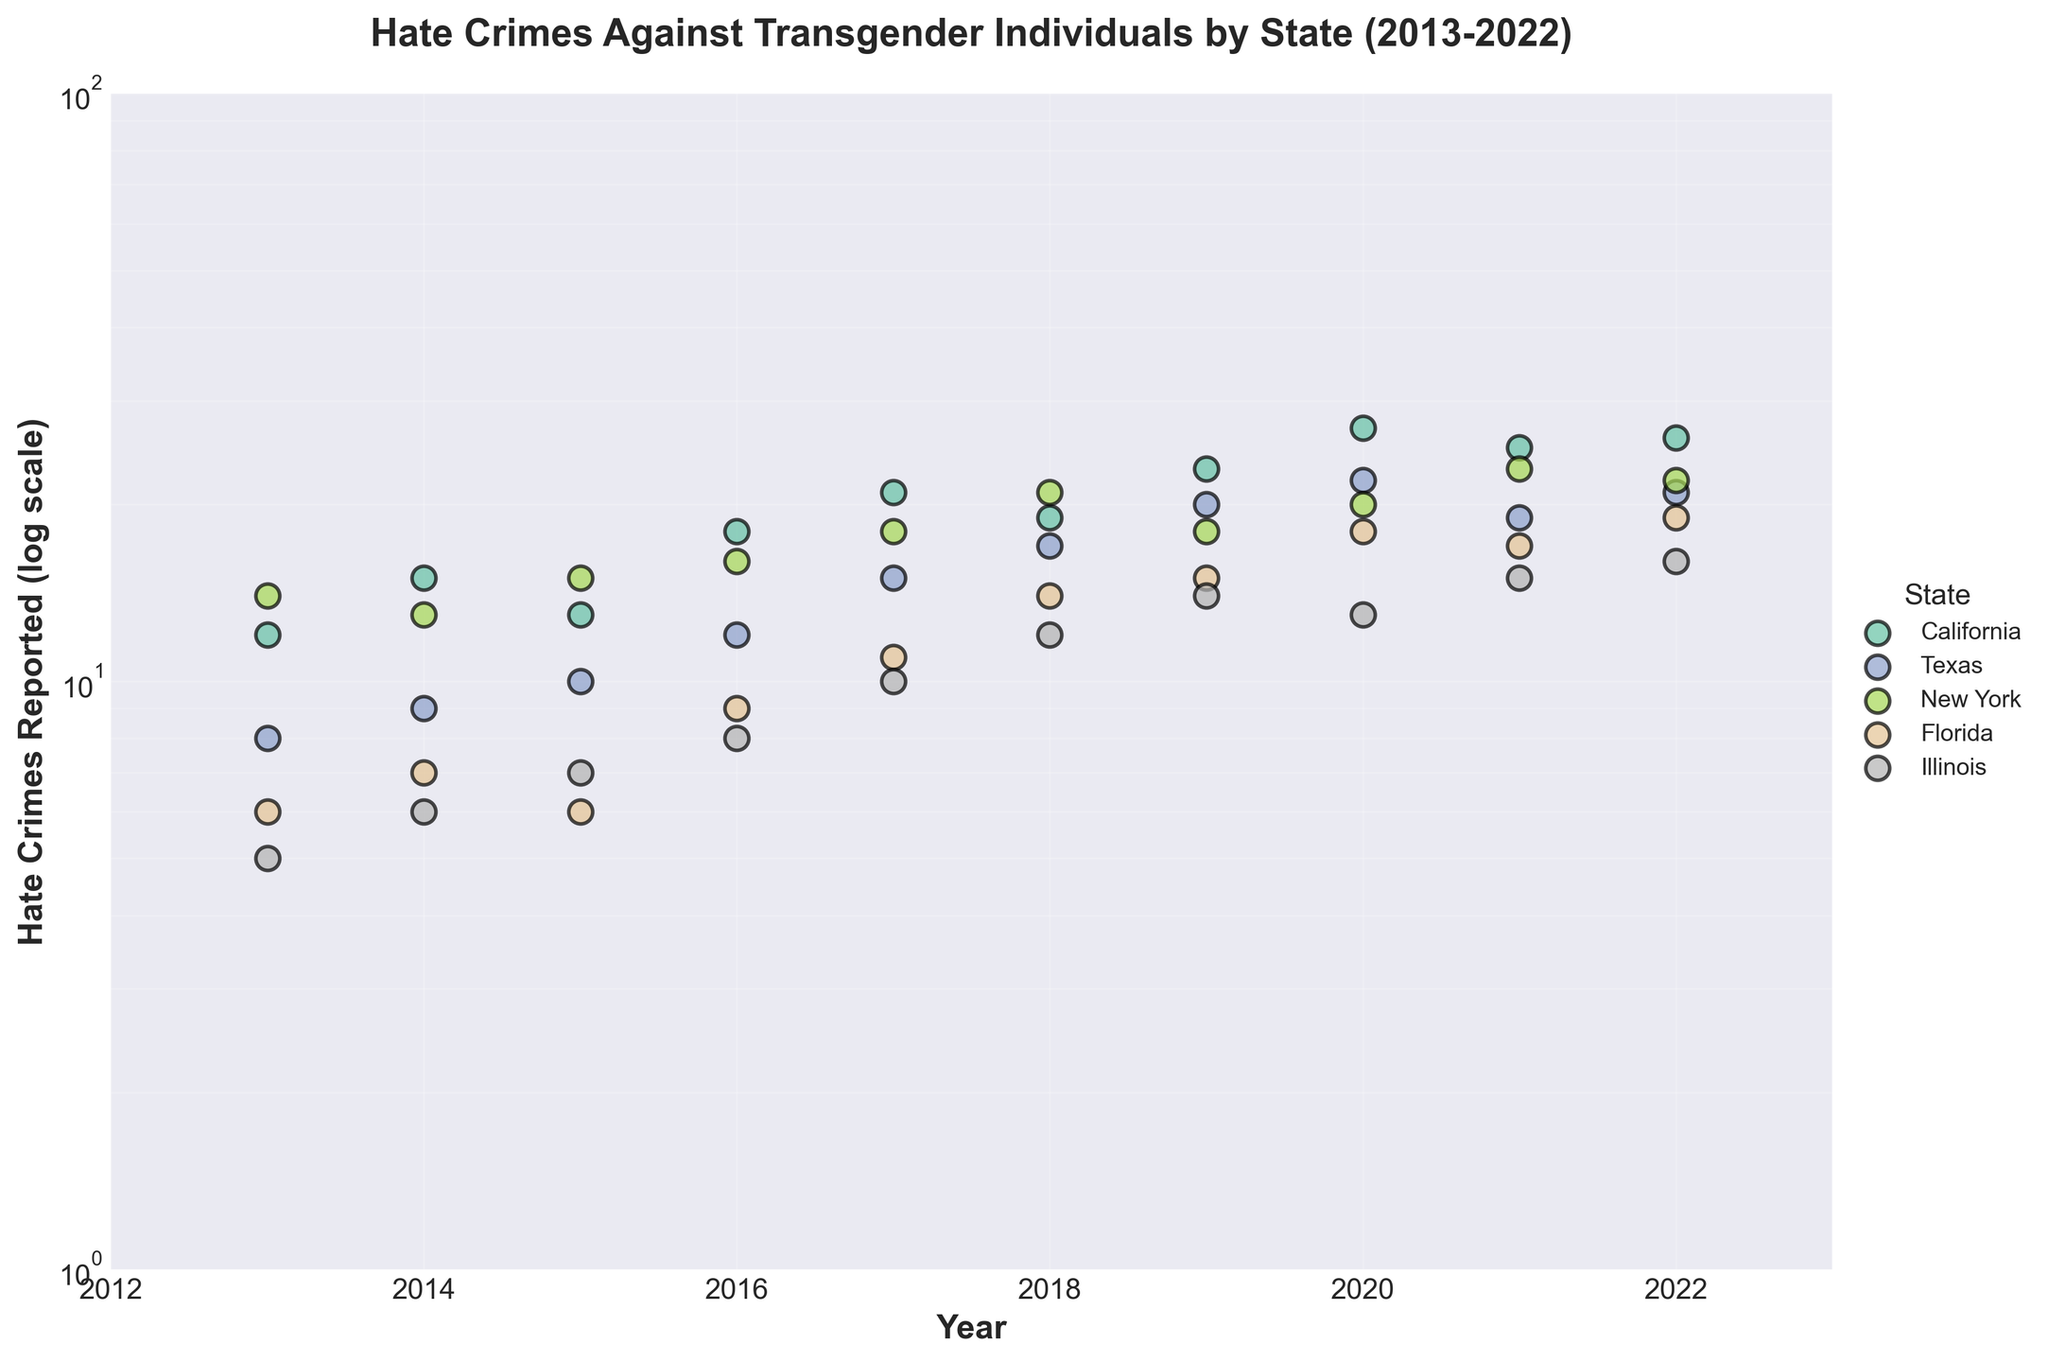What is the title of the figure? The title is typically located at the top of the figure. It is usually larger and bold.
Answer: Hate Crimes Against Transgender Individuals by State (2013-2022) Which state had the highest number of hate crimes reported in 2022? Observe the y-axis values for the year 2022, then identify the state corresponding to the highest y-axis value.
Answer: California How many hate crime incidents against transgender individuals were reported in Texas in 2017? Locate the section of the scatter plot corresponding to Texas for the year 2017, then read the y-value.
Answer: 15 Which state showed the greatest increase in hate crimes reported from 2013 to 2022? Compare the y-axis values for each state between 2013 and 2022. Subtract the 2013 value from the 2022 value for each state. The state with the highest difference is the answer.
Answer: California Does New York report show a consistent upward trend across the years? Follow the progression of data points for New York through the years, checking for consistent increases in the y-values.
Answer: No Which state reported fewer hate crimes than any other in 2013? Identify the smallest y-value for the year 2013 and the corresponding state.
Answer: Illinois Between which years does Florida experience the highest increase in reported hate crimes? Examine the y-values for Florida for consecutive year pairs and find the pair with the largest increase.
Answer: 2017 to 2018 How does the trend in Texas compare to the trend in Illinois from 2013 to 2022? Compare the slopes of the trends over time for Texas and Illinois. Observe if they move in the same direction (upward) and note any similar changes through the years.
Answer: Both increase, but Texas has more distinct yearly peaks What is the range of hate crimes reported in New York during the decade covered? Find the minimum and maximum y-values for New York across all years, then compute the difference.
Answer: Range is 14 to 23 Are there any states where hate crimes decrease toward the end of the observed period (2021-2022)? Look specifically at the years 2021 and 2022 for all states to see if any y-values decrease in this interval.
Answer: Texas, New York 